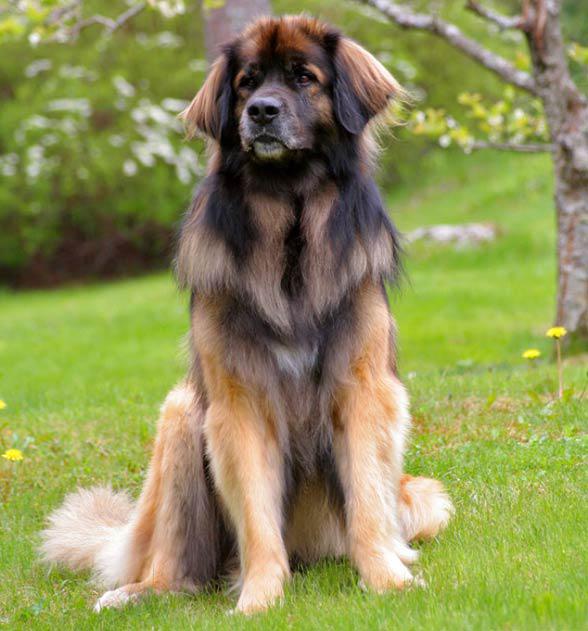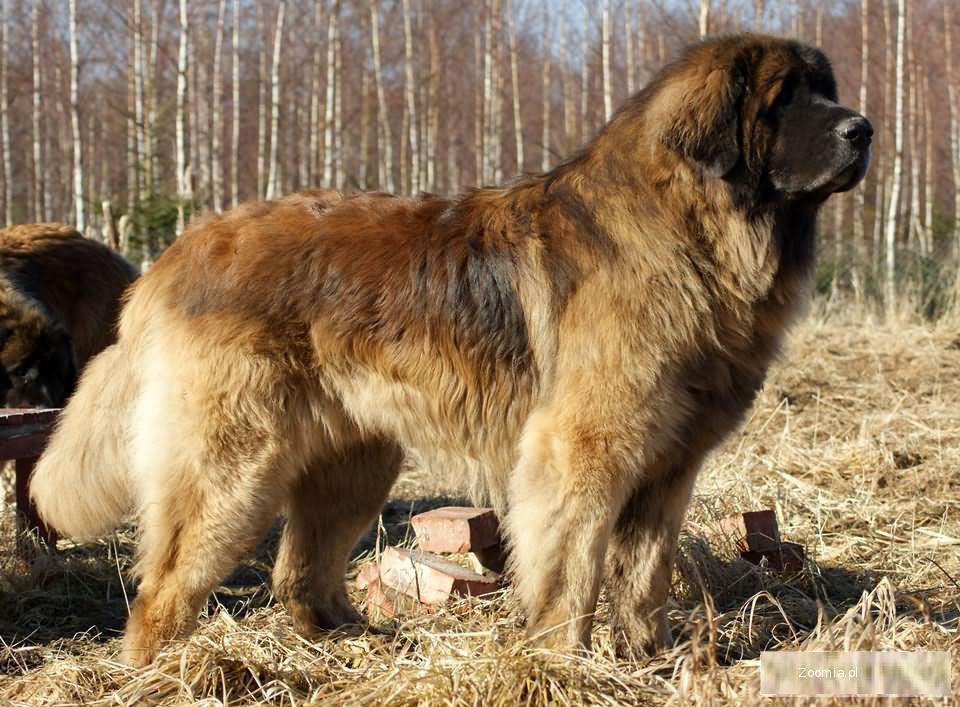The first image is the image on the left, the second image is the image on the right. Considering the images on both sides, is "There are two dogs in one of the images." valid? Answer yes or no. No. 